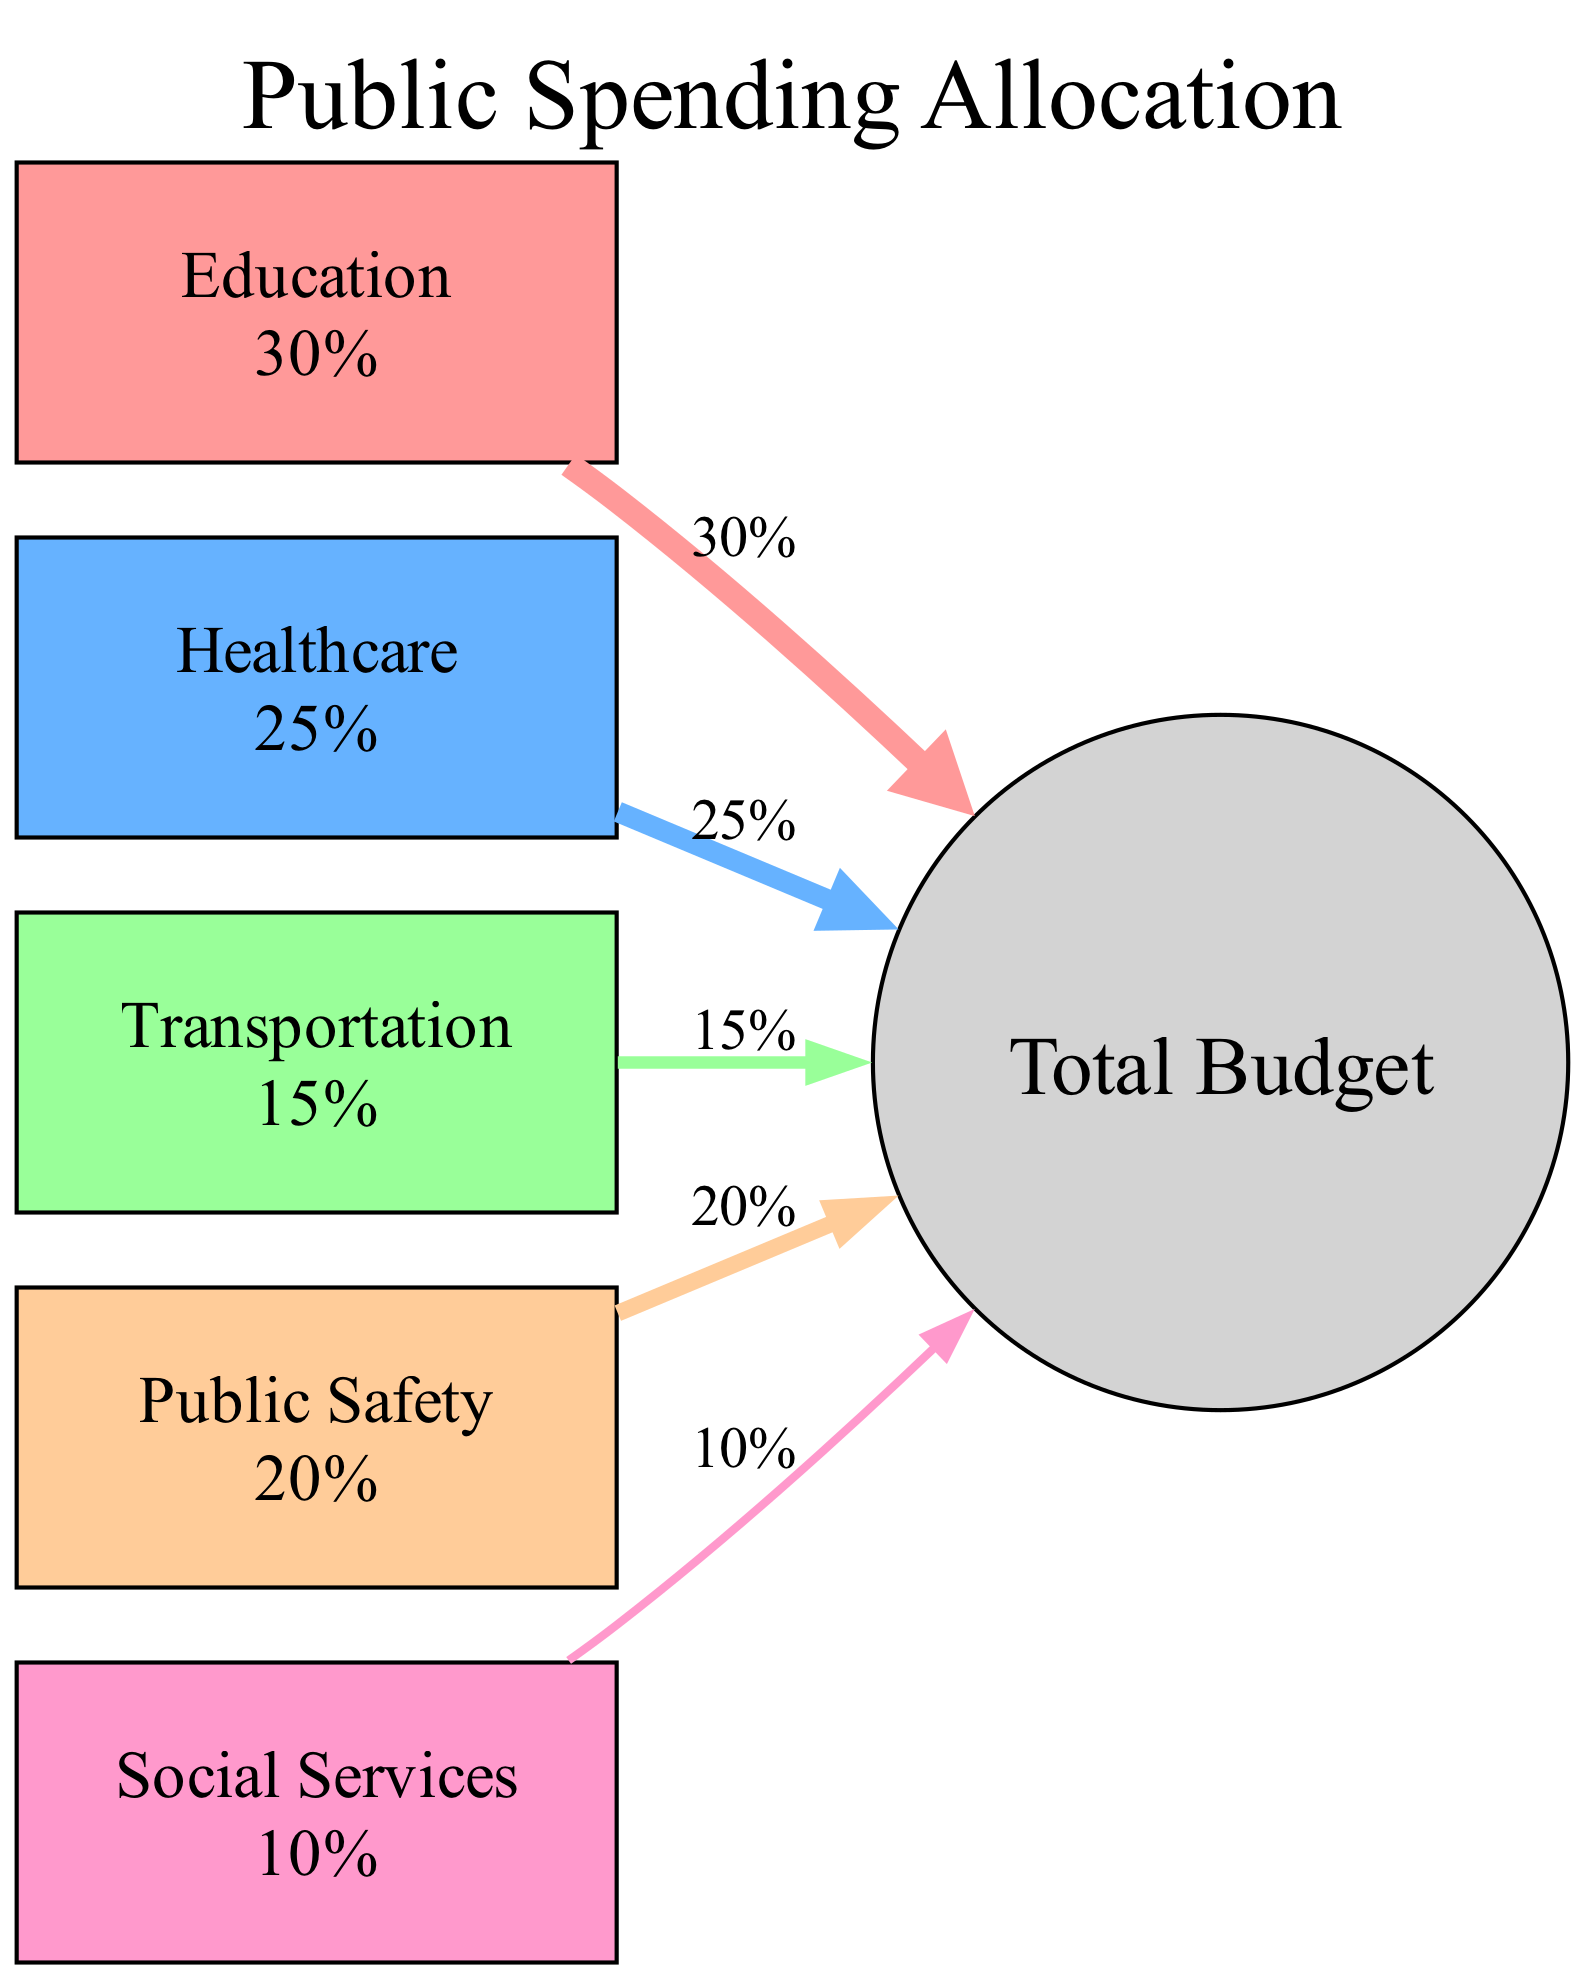What is the percentage of the budget allocated to healthcare? The diagram shows that healthcare has a specific node labeled "Healthcare" with a percentage value displayed next to it. According to the data, the percentage allocated to healthcare is 25%.
Answer: 25% Which sector has the highest budget allocation? By examining the nodes in the diagram, we look for the one with the highest percentage. The "Education" node indicates a 30% allocation, which is the highest compared to the other sectors.
Answer: Education How many sectors are represented in the diagram? The diagram consists of individual nodes for each sector, which are clearly labeled. Counting these nodes, there are five distinct sectors: Education, Healthcare, Transportation, Public Safety, and Social Services.
Answer: 5 What is the total percentage allocated to public safety? The "Public Safety" node contains a label indicating its percentage allocation. Upon inspection, it is stated as 20%.
Answer: 20% Which two sectors together constitute 55% of the total budget? We need to add the percentage of Education (30%) and Healthcare (25%) to find the total. Adding these numbers together, 30% + 25% = 55%. Therefore, these two sectors together make up 55% of the total budget.
Answer: Education and Healthcare How thick is the edge representing social services? The thickness of an edge is related to the percentage represented by the corresponding sector. The edge for social services, which has a 10% allocation, will have a thickness calculated as the percentage divided by 5, resulting in 10% / 5 = 2.
Answer: 2 Which sector has the least funding in this diagram? To determine the sector with the least funding, we look at the percentage values of all nodes. The "Social Services" node has the lowest allocation, which is 10%.
Answer: Social Services What is the total budget allocation for transportation and public safety? The values for transportation (15%) and public safety (20%) can be summed to find the total allocation. Performing the addition, 15% + 20% gives a total of 35%.
Answer: 35% 